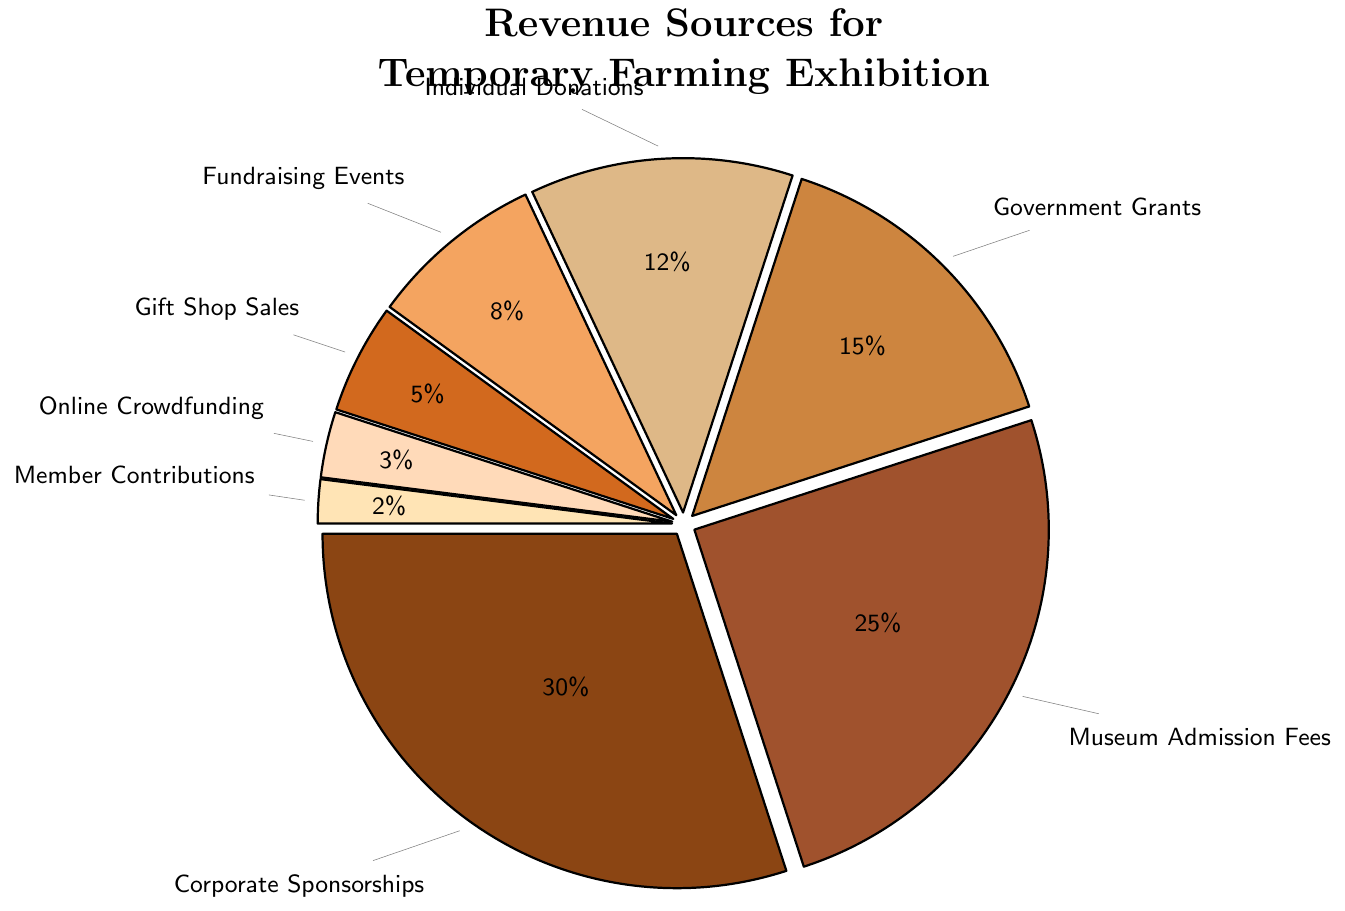What is the largest revenue source for the temporary farming exhibition? The largest segment in the pie chart is labeled "Corporate Sponsorships," which makes up 30% of the total revenue.
Answer: Corporate Sponsorships How much more revenue is generated from Museum Admission Fees compared to Gift Shop Sales? Museum Admission Fees contribute 25% and Gift Shop Sales contribute 5%. The difference is 25% - 5% = 20%.
Answer: 20% Which revenue sources contribute more than 10% each? By examining the pie chart, the categories that contribute more than 10% are Corporate Sponsorships (30%), Museum Admission Fees (25%), Government Grants (15%), and Individual Donations (12%).
Answer: Corporate Sponsorships, Museum Admission Fees, Government Grants, Individual Donations What is the difference in percentage between the third and fourth highest revenue sources? The third highest is Government Grants at 15% and the fourth highest is Individual Donations at 12%. The difference is 15% - 12% = 3%.
Answer: 3% Which source contributes the least to the total revenue? The smallest segment in the pie chart is labeled "Member Contributions," which makes up 2% of the total revenue.
Answer: Member Contributions If the revenue from Corporate Sponsorships and Museum Admission Fees were combined, what would be their total contribution percentage? Combining Corporate Sponsorships (30%) and Museum Admission Fees (25%) gives 30% + 25% = 55%.
Answer: 55% Which revenue sources are less than 10% each? The pie chart shows Fundraising Events (8%), Gift Shop Sales (5%), Online Crowdfunding (3%), and Member Contributions (2%) each contributing less than 10%.
Answer: Fundraising Events, Gift Shop Sales, Online Crowdfunding, Member Contributions What is the average contribution percentage of Individual Donations and Fundraising Events? Individual Donations contribute 12% and Fundraising Events contribute 8%. The average is (12% + 8%) / 2 = 20% / 2 = 10%.
Answer: 10% Which segment is visually represented with the brown color? The largest segment, Corporate Sponsorships (30%), is visually represented with the brown color as per the predefined colors in the chart.
Answer: Corporate Sponsorships 